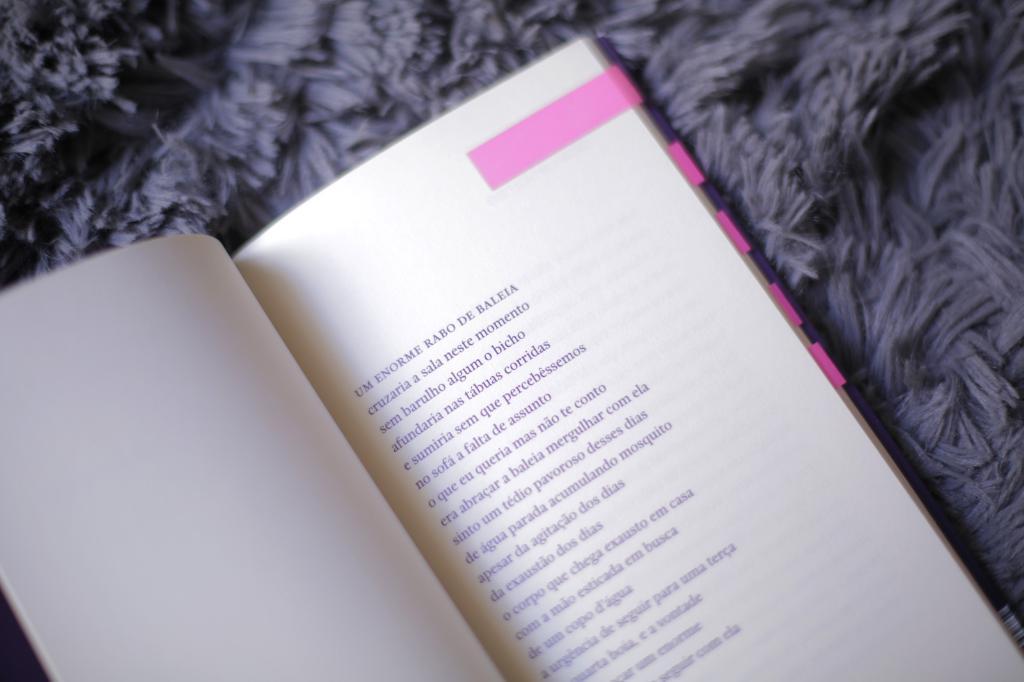What is the first line?
Give a very brief answer. Um enorme rabo de baleia. 